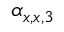<formula> <loc_0><loc_0><loc_500><loc_500>\alpha _ { x , x , 3 }</formula> 